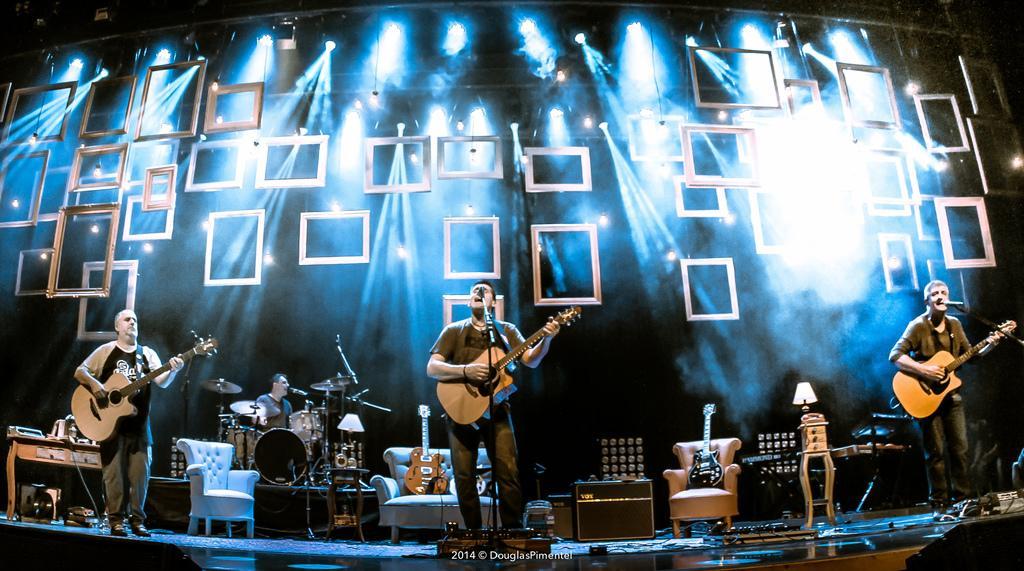Describe this image in one or two sentences. In this image we can see this people are holding a guitar and playing it. This people are singing through the mics. This person is sitting and playing electronic drums. We can see chairs, lamp, guitars, table and show lights in the background. 